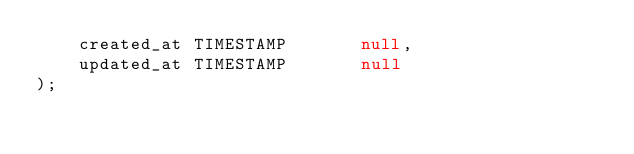Convert code to text. <code><loc_0><loc_0><loc_500><loc_500><_SQL_>    created_at TIMESTAMP       null,
    updated_at TIMESTAMP       null
);
</code> 